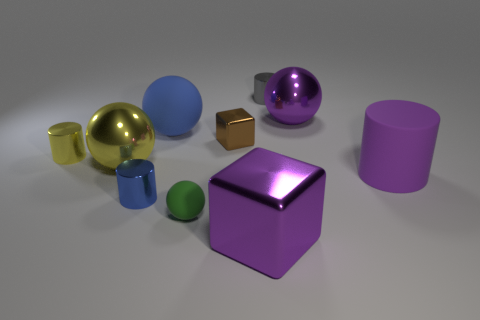What number of yellow cylinders are in front of the small green object?
Your answer should be compact. 0. There is a cube that is the same material as the brown thing; what is its color?
Make the answer very short. Purple. Do the brown metallic block and the metal sphere on the left side of the tiny green sphere have the same size?
Your response must be concise. No. What is the size of the purple cube in front of the blue thing behind the small metal cylinder that is in front of the large purple rubber cylinder?
Make the answer very short. Large. What number of matte objects are either tiny brown things or big cylinders?
Provide a short and direct response. 1. There is a large shiny sphere on the right side of the brown metallic cube; what color is it?
Provide a short and direct response. Purple. What is the shape of the gray object that is the same size as the yellow metal cylinder?
Provide a succinct answer. Cylinder. There is a tiny ball; does it have the same color as the small cylinder that is in front of the purple cylinder?
Your answer should be compact. No. What number of objects are either metallic balls that are on the right side of the purple cube or big rubber objects to the left of the big purple metallic cube?
Your response must be concise. 2. There is a blue cylinder that is the same size as the green sphere; what is its material?
Offer a very short reply. Metal. 